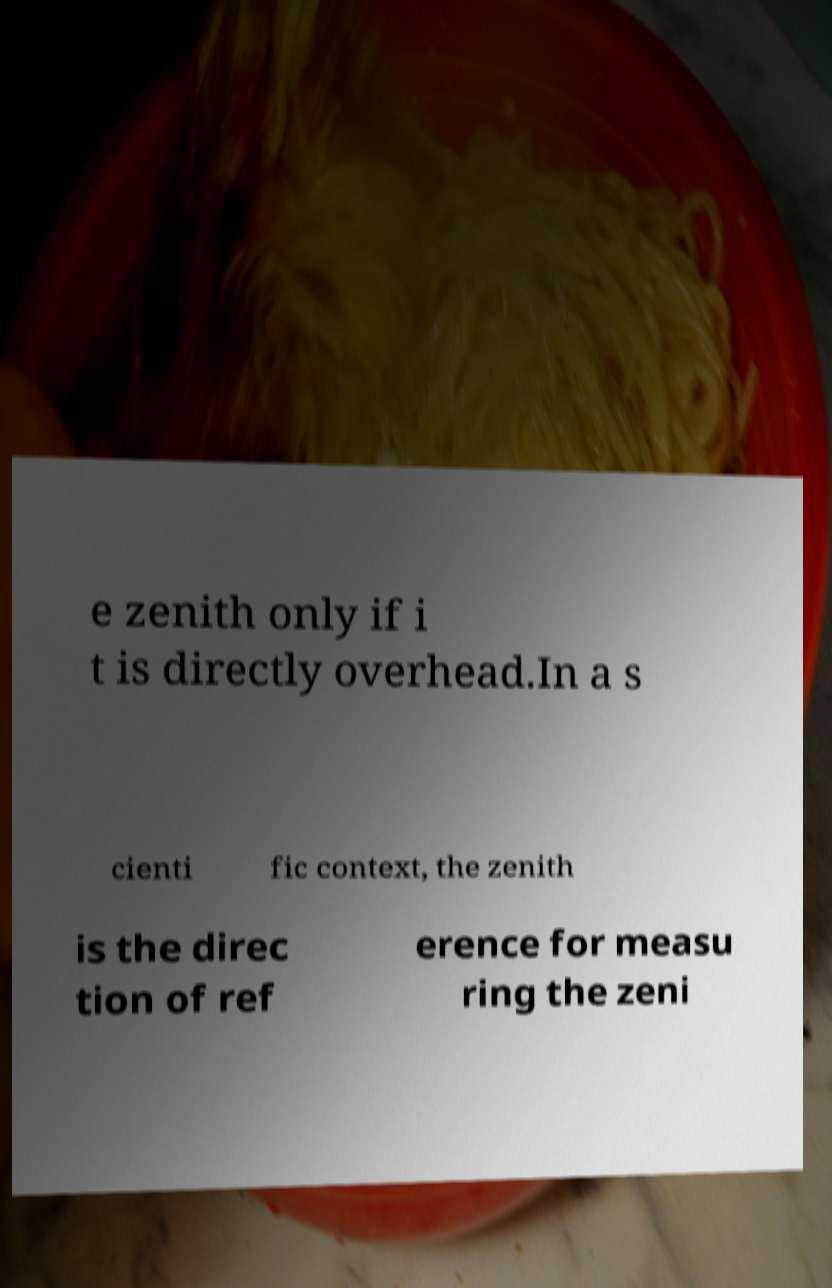Can you read and provide the text displayed in the image?This photo seems to have some interesting text. Can you extract and type it out for me? e zenith only if i t is directly overhead.In a s cienti fic context, the zenith is the direc tion of ref erence for measu ring the zeni 